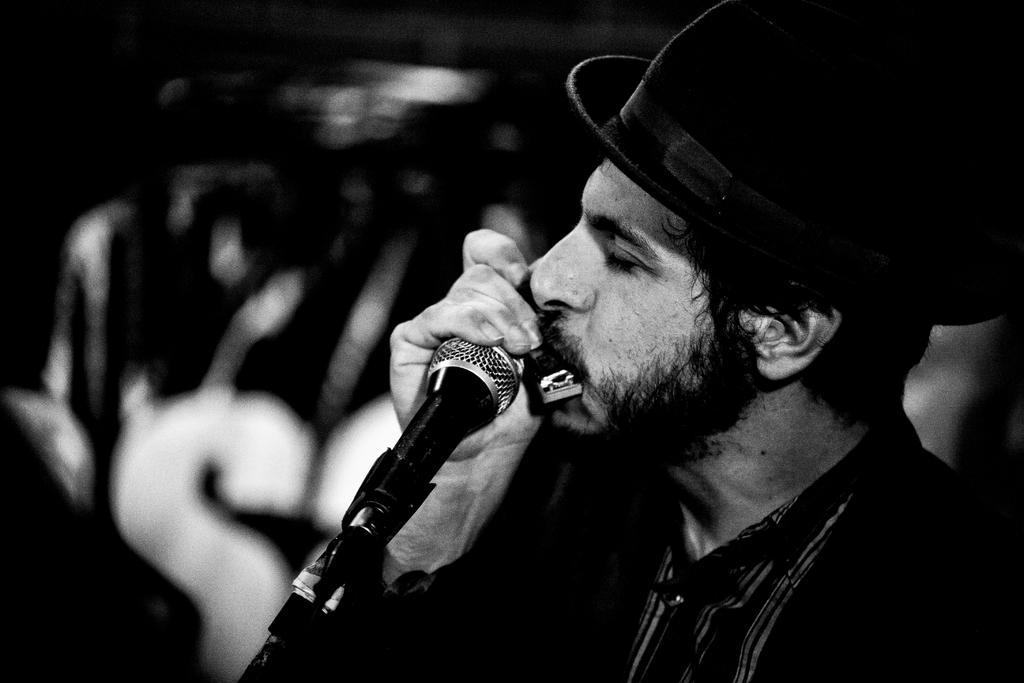What is the main subject of the image? There is a man in the image. What is the man holding in the image? The man is holding a musical instrument. What device is present for amplifying sound in the image? There is a microphone in the image. What object is present for supporting the musical instrument or other items in the image? There is a stand in the image. Can you see a river in the background of the image? There is no river visible in the image. Is there an argument taking place between the man and the microphone in the image? There is no argument depicted in the image; the man is simply holding a musical instrument and there is a microphone present. 